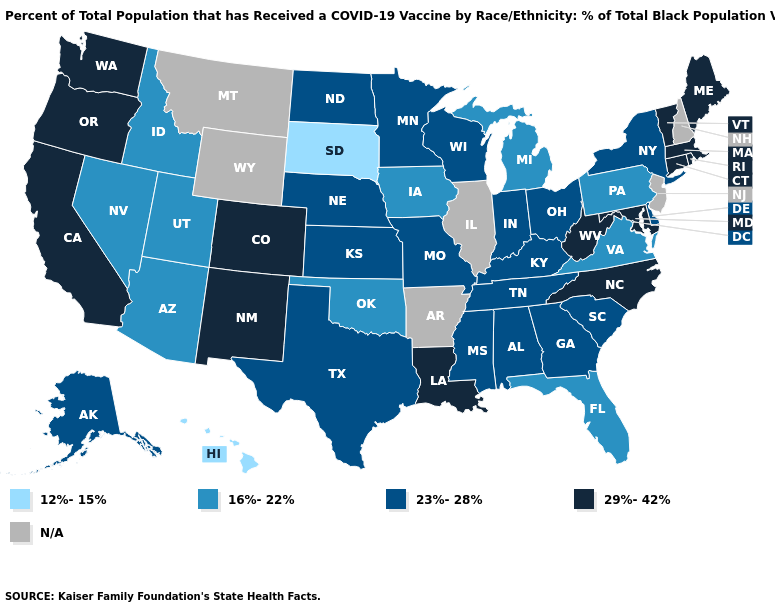What is the value of Wyoming?
Answer briefly. N/A. What is the lowest value in the South?
Give a very brief answer. 16%-22%. What is the highest value in states that border Tennessee?
Answer briefly. 29%-42%. Which states have the lowest value in the MidWest?
Quick response, please. South Dakota. What is the value of North Dakota?
Keep it brief. 23%-28%. Name the states that have a value in the range 12%-15%?
Short answer required. Hawaii, South Dakota. What is the lowest value in the USA?
Be succinct. 12%-15%. What is the value of Idaho?
Short answer required. 16%-22%. Does Alaska have the highest value in the West?
Keep it brief. No. Does Utah have the highest value in the West?
Keep it brief. No. Does Pennsylvania have the lowest value in the Northeast?
Short answer required. Yes. Which states hav the highest value in the Northeast?
Give a very brief answer. Connecticut, Maine, Massachusetts, Rhode Island, Vermont. Does the first symbol in the legend represent the smallest category?
Quick response, please. Yes. 